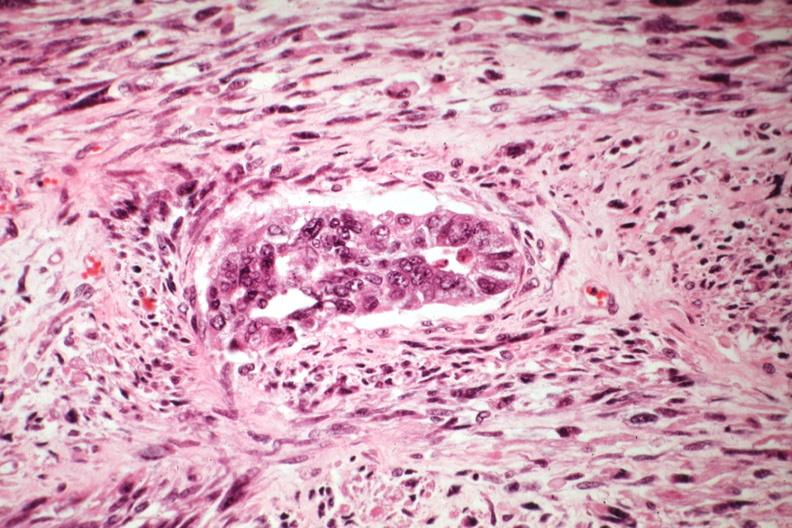what is present?
Answer the question using a single word or phrase. Female reproductive 